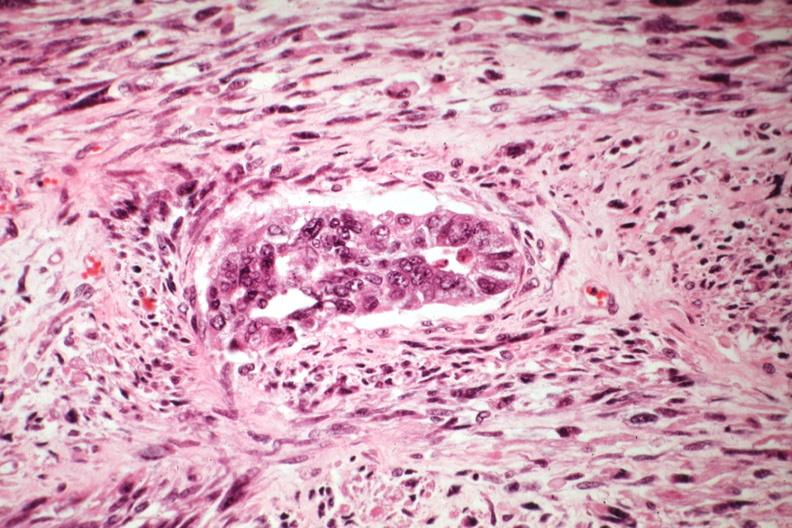what is present?
Answer the question using a single word or phrase. Female reproductive 